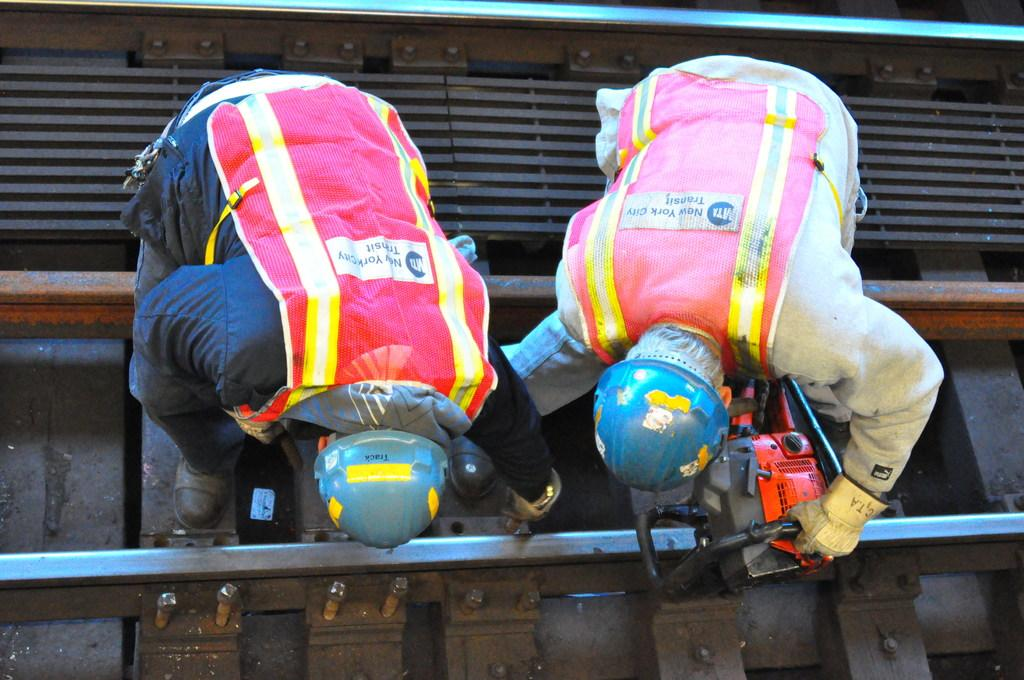What are the persons in the image doing? The persons in the image are working on a railway track. What type of work might they be performing on the railway track? They might be performing maintenance, repairs, or inspections on the railway track. What type of stove can be seen in the image? There is no stove present in the image. What fact can be determined about the number of cats in the image? There is no information about cats in the image, so no fact about their number can be determined. 